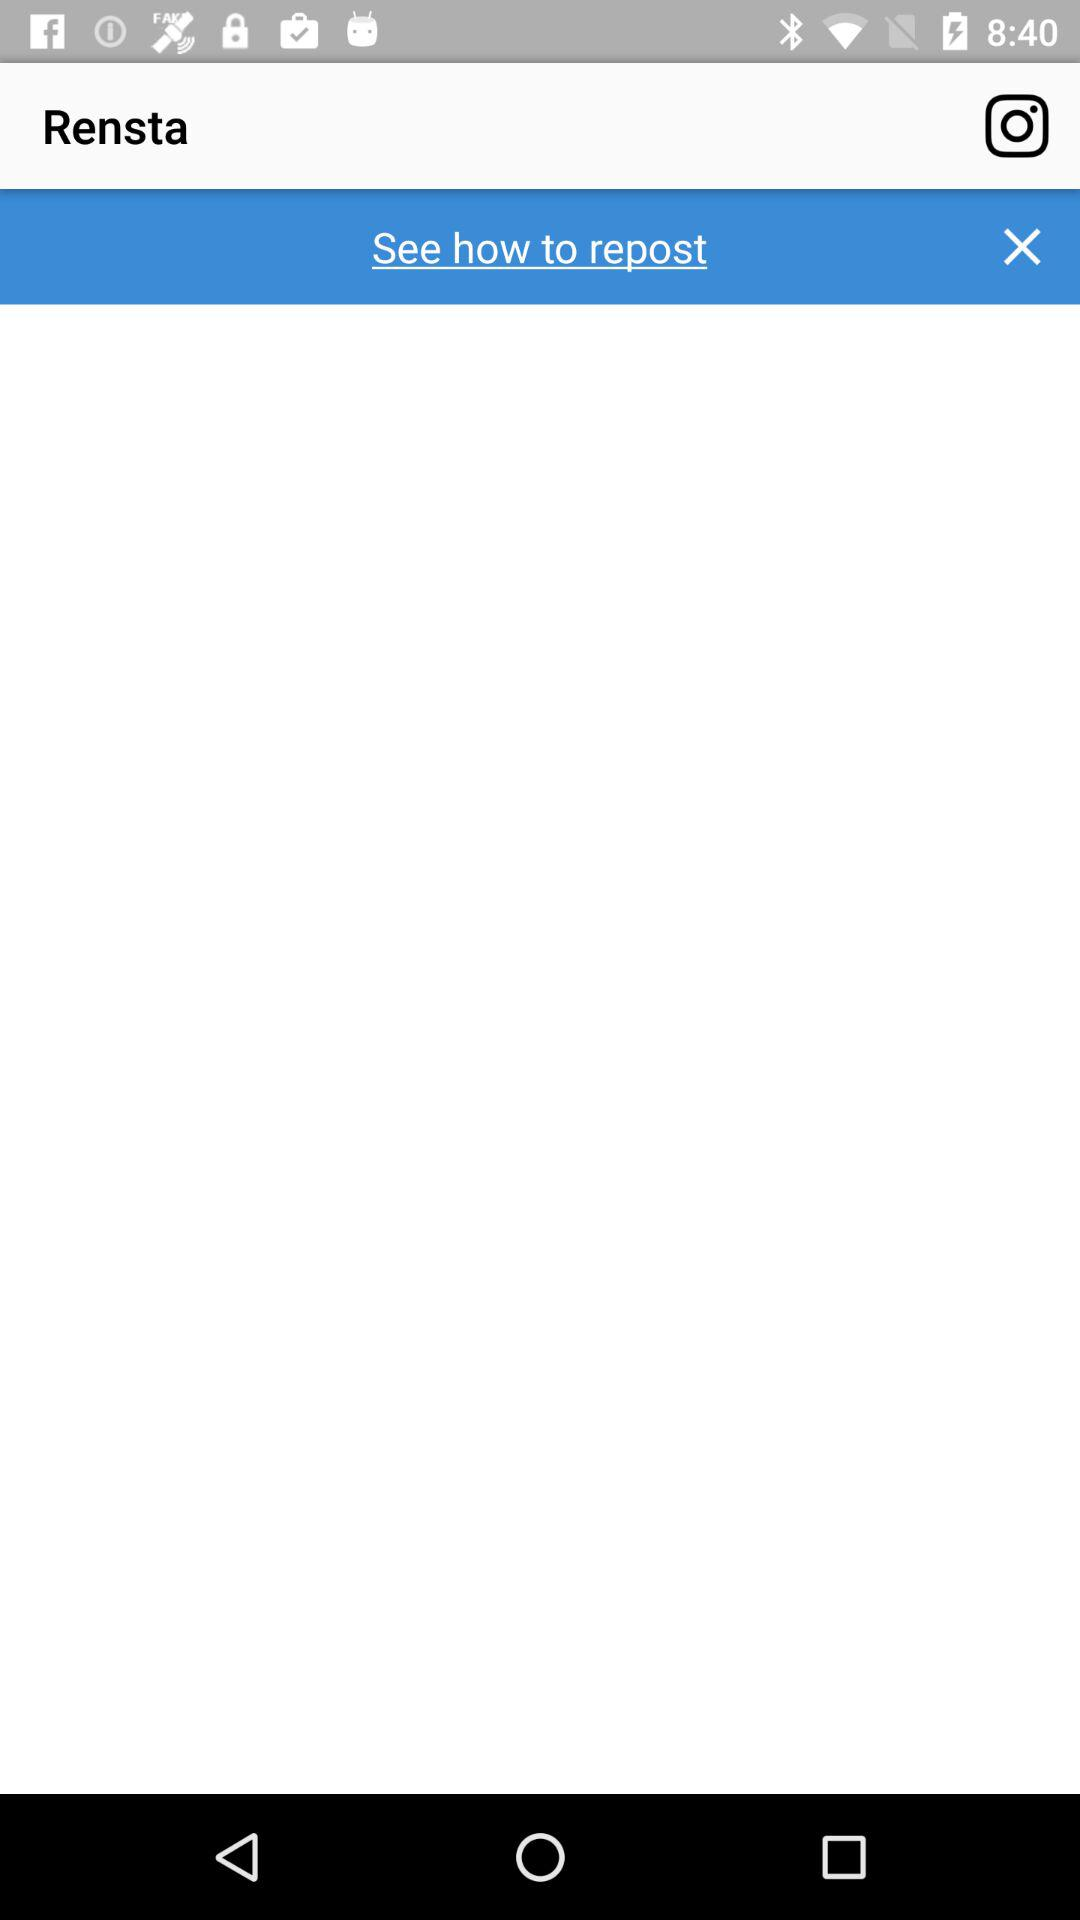How many likes does the application have?
When the provided information is insufficient, respond with <no answer>. <no answer> 